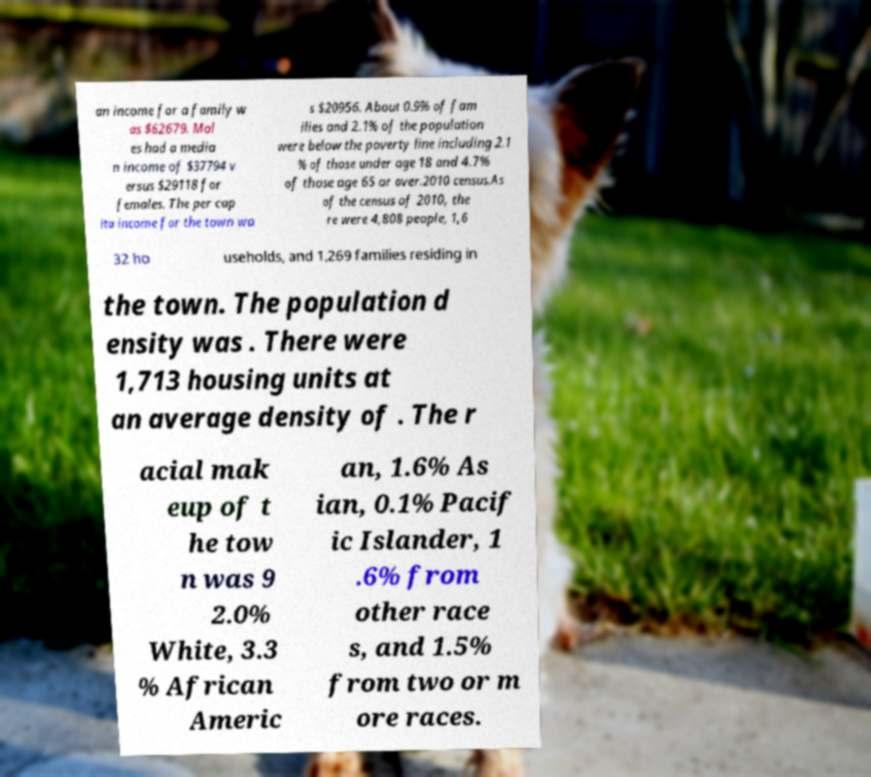Can you read and provide the text displayed in the image?This photo seems to have some interesting text. Can you extract and type it out for me? an income for a family w as $62679. Mal es had a media n income of $37794 v ersus $29118 for females. The per cap ita income for the town wa s $20956. About 0.9% of fam ilies and 2.1% of the population were below the poverty line including 2.1 % of those under age 18 and 4.7% of those age 65 or over.2010 census.As of the census of 2010, the re were 4,808 people, 1,6 32 ho useholds, and 1,269 families residing in the town. The population d ensity was . There were 1,713 housing units at an average density of . The r acial mak eup of t he tow n was 9 2.0% White, 3.3 % African Americ an, 1.6% As ian, 0.1% Pacif ic Islander, 1 .6% from other race s, and 1.5% from two or m ore races. 